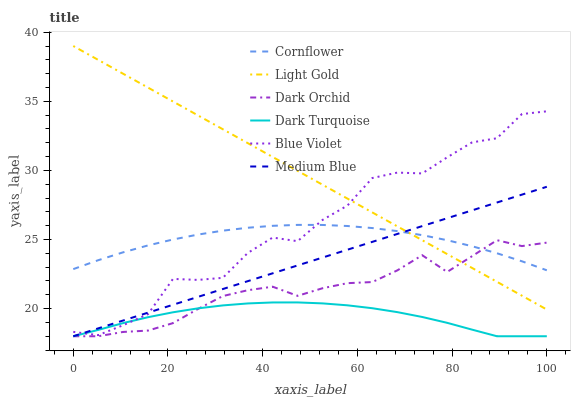Does Dark Turquoise have the minimum area under the curve?
Answer yes or no. Yes. Does Light Gold have the maximum area under the curve?
Answer yes or no. Yes. Does Medium Blue have the minimum area under the curve?
Answer yes or no. No. Does Medium Blue have the maximum area under the curve?
Answer yes or no. No. Is Medium Blue the smoothest?
Answer yes or no. Yes. Is Blue Violet the roughest?
Answer yes or no. Yes. Is Dark Turquoise the smoothest?
Answer yes or no. No. Is Dark Turquoise the roughest?
Answer yes or no. No. Does Dark Turquoise have the lowest value?
Answer yes or no. Yes. Does Light Gold have the lowest value?
Answer yes or no. No. Does Light Gold have the highest value?
Answer yes or no. Yes. Does Medium Blue have the highest value?
Answer yes or no. No. Is Dark Turquoise less than Cornflower?
Answer yes or no. Yes. Is Light Gold greater than Dark Turquoise?
Answer yes or no. Yes. Does Medium Blue intersect Dark Turquoise?
Answer yes or no. Yes. Is Medium Blue less than Dark Turquoise?
Answer yes or no. No. Is Medium Blue greater than Dark Turquoise?
Answer yes or no. No. Does Dark Turquoise intersect Cornflower?
Answer yes or no. No. 